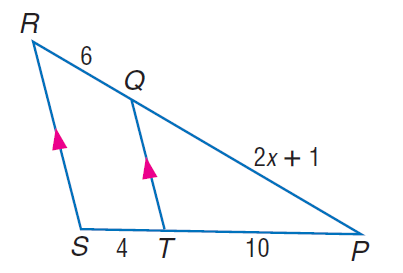Question: Find x.
Choices:
A. 7
B. 9
C. 12
D. 15
Answer with the letter. Answer: A Question: Find P Q.
Choices:
A. 12
B. 15
C. 16
D. 18
Answer with the letter. Answer: B 